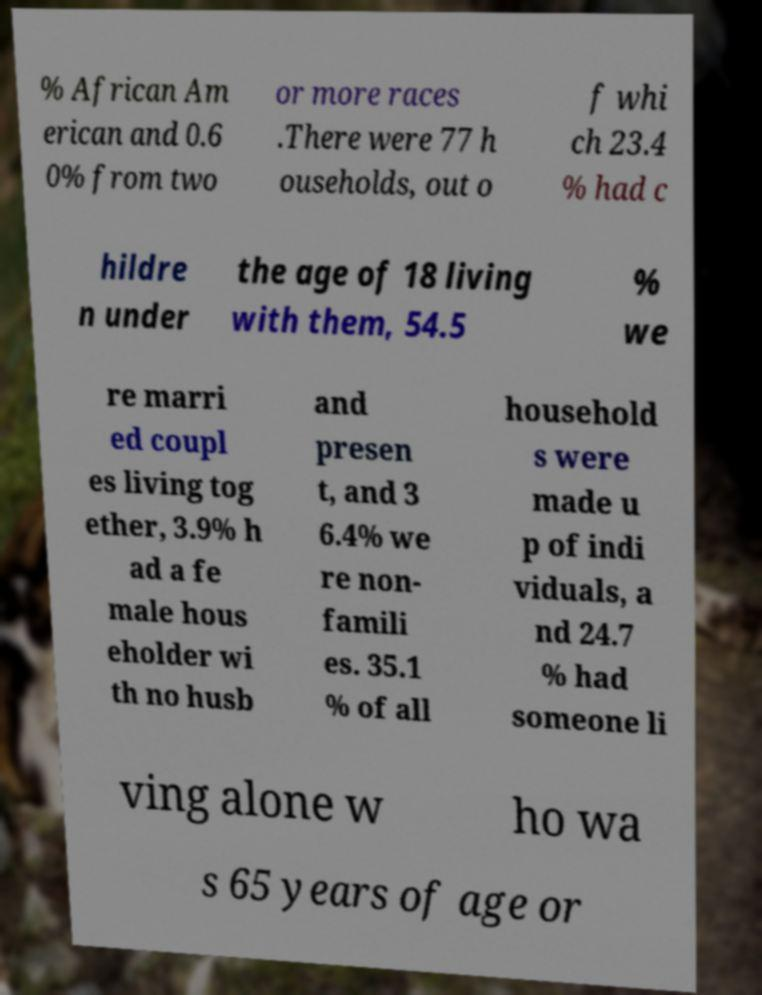Could you assist in decoding the text presented in this image and type it out clearly? % African Am erican and 0.6 0% from two or more races .There were 77 h ouseholds, out o f whi ch 23.4 % had c hildre n under the age of 18 living with them, 54.5 % we re marri ed coupl es living tog ether, 3.9% h ad a fe male hous eholder wi th no husb and presen t, and 3 6.4% we re non- famili es. 35.1 % of all household s were made u p of indi viduals, a nd 24.7 % had someone li ving alone w ho wa s 65 years of age or 